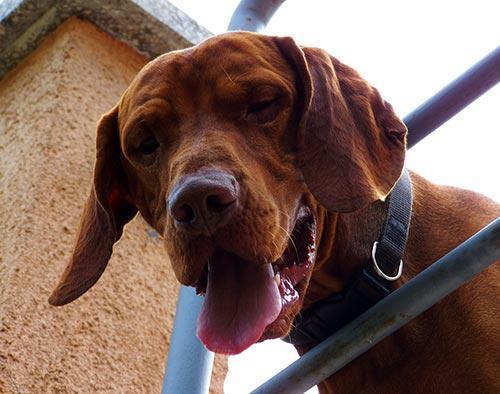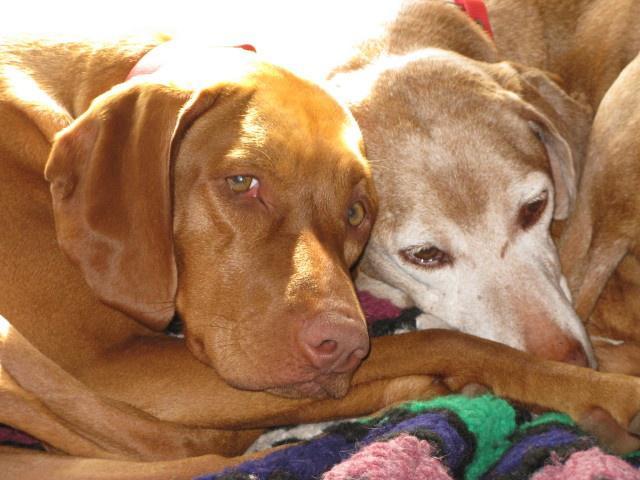The first image is the image on the left, the second image is the image on the right. Given the left and right images, does the statement "Two dogs are looking into the camera." hold true? Answer yes or no. Yes. The first image is the image on the left, the second image is the image on the right. Given the left and right images, does the statement "The left image includes at least one extended paw in the foreground, and a collar worn by a reclining dog." hold true? Answer yes or no. No. 